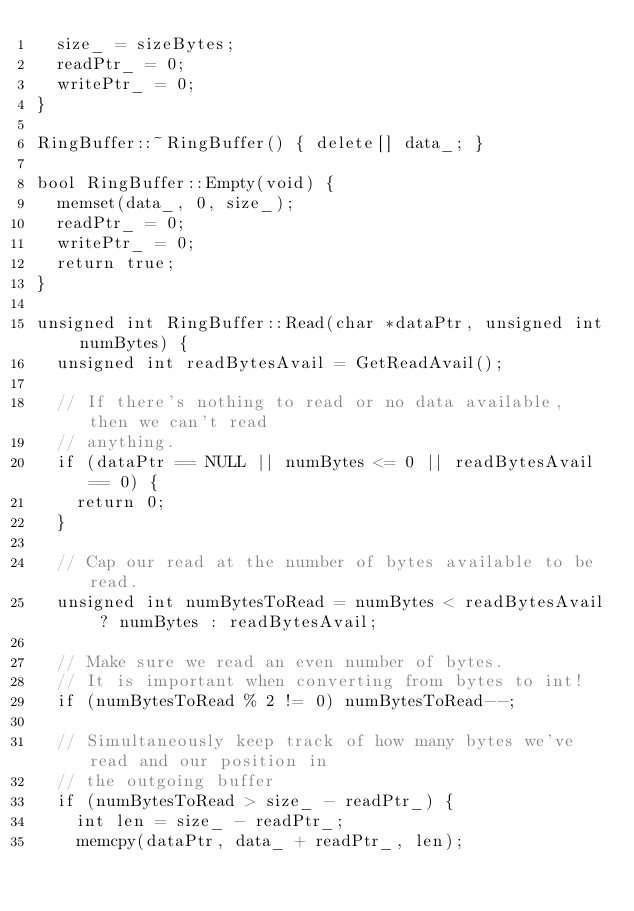Convert code to text. <code><loc_0><loc_0><loc_500><loc_500><_C++_>  size_ = sizeBytes;
  readPtr_ = 0;
  writePtr_ = 0;
}

RingBuffer::~RingBuffer() { delete[] data_; }

bool RingBuffer::Empty(void) {
  memset(data_, 0, size_);
  readPtr_ = 0;
  writePtr_ = 0;
  return true;
}

unsigned int RingBuffer::Read(char *dataPtr, unsigned int numBytes) {
  unsigned int readBytesAvail = GetReadAvail();

  // If there's nothing to read or no data available, then we can't read
  // anything.
  if (dataPtr == NULL || numBytes <= 0 || readBytesAvail == 0) {
    return 0;
  }

  // Cap our read at the number of bytes available to be read.
  unsigned int numBytesToRead = numBytes < readBytesAvail ? numBytes : readBytesAvail;

  // Make sure we read an even number of bytes. 
  // It is important when converting from bytes to int!
  if (numBytesToRead % 2 != 0) numBytesToRead--;

  // Simultaneously keep track of how many bytes we've read and our position in
  // the outgoing buffer
  if (numBytesToRead > size_ - readPtr_) {
    int len = size_ - readPtr_;
    memcpy(dataPtr, data_ + readPtr_, len);</code> 